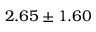Convert formula to latex. <formula><loc_0><loc_0><loc_500><loc_500>2 . 6 5 \pm 1 . 6 0</formula> 